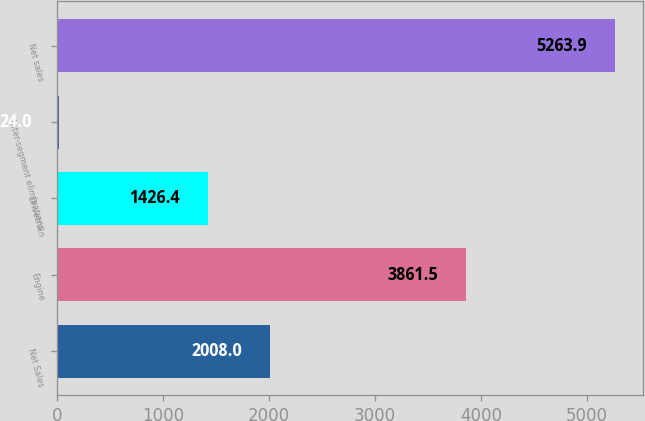Convert chart. <chart><loc_0><loc_0><loc_500><loc_500><bar_chart><fcel>Net Sales<fcel>Engine<fcel>Drivetrain<fcel>Inter-segment eliminations<fcel>Net sales<nl><fcel>2008<fcel>3861.5<fcel>1426.4<fcel>24<fcel>5263.9<nl></chart> 